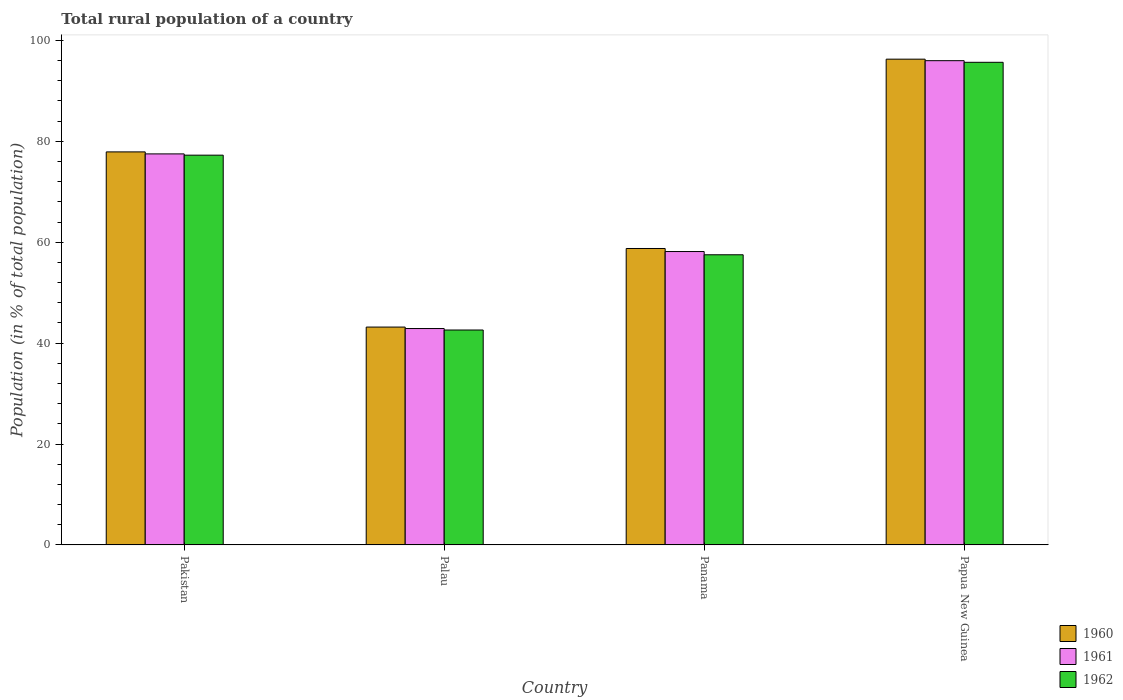How many groups of bars are there?
Give a very brief answer. 4. What is the label of the 4th group of bars from the left?
Keep it short and to the point. Papua New Guinea. What is the rural population in 1960 in Panama?
Offer a very short reply. 58.75. Across all countries, what is the maximum rural population in 1962?
Make the answer very short. 95.65. Across all countries, what is the minimum rural population in 1960?
Give a very brief answer. 43.18. In which country was the rural population in 1962 maximum?
Provide a short and direct response. Papua New Guinea. In which country was the rural population in 1961 minimum?
Offer a terse response. Palau. What is the total rural population in 1962 in the graph?
Provide a succinct answer. 273. What is the difference between the rural population in 1962 in Pakistan and that in Papua New Guinea?
Give a very brief answer. -18.4. What is the difference between the rural population in 1960 in Panama and the rural population in 1962 in Pakistan?
Provide a short and direct response. -18.5. What is the average rural population in 1962 per country?
Offer a terse response. 68.25. What is the difference between the rural population of/in 1960 and rural population of/in 1961 in Palau?
Your answer should be compact. 0.29. What is the ratio of the rural population in 1960 in Palau to that in Panama?
Keep it short and to the point. 0.73. Is the difference between the rural population in 1960 in Palau and Panama greater than the difference between the rural population in 1961 in Palau and Panama?
Keep it short and to the point. No. What is the difference between the highest and the second highest rural population in 1961?
Your response must be concise. -19.35. What is the difference between the highest and the lowest rural population in 1960?
Ensure brevity in your answer.  53.1. Is the sum of the rural population in 1962 in Palau and Panama greater than the maximum rural population in 1961 across all countries?
Your answer should be very brief. Yes. What does the 3rd bar from the left in Palau represents?
Offer a terse response. 1962. What does the 2nd bar from the right in Pakistan represents?
Your answer should be very brief. 1961. Is it the case that in every country, the sum of the rural population in 1961 and rural population in 1960 is greater than the rural population in 1962?
Ensure brevity in your answer.  Yes. Are all the bars in the graph horizontal?
Ensure brevity in your answer.  No. Does the graph contain any zero values?
Your answer should be compact. No. Does the graph contain grids?
Ensure brevity in your answer.  No. What is the title of the graph?
Your answer should be very brief. Total rural population of a country. Does "1993" appear as one of the legend labels in the graph?
Keep it short and to the point. No. What is the label or title of the X-axis?
Offer a very short reply. Country. What is the label or title of the Y-axis?
Your response must be concise. Population (in % of total population). What is the Population (in % of total population) in 1960 in Pakistan?
Give a very brief answer. 77.9. What is the Population (in % of total population) in 1961 in Pakistan?
Provide a succinct answer. 77.5. What is the Population (in % of total population) in 1962 in Pakistan?
Offer a very short reply. 77.25. What is the Population (in % of total population) in 1960 in Palau?
Offer a terse response. 43.18. What is the Population (in % of total population) in 1961 in Palau?
Provide a short and direct response. 42.89. What is the Population (in % of total population) in 1962 in Palau?
Your answer should be compact. 42.59. What is the Population (in % of total population) of 1960 in Panama?
Provide a succinct answer. 58.75. What is the Population (in % of total population) of 1961 in Panama?
Your answer should be very brief. 58.15. What is the Population (in % of total population) in 1962 in Panama?
Provide a succinct answer. 57.51. What is the Population (in % of total population) of 1960 in Papua New Guinea?
Keep it short and to the point. 96.28. What is the Population (in % of total population) of 1961 in Papua New Guinea?
Provide a short and direct response. 95.98. What is the Population (in % of total population) of 1962 in Papua New Guinea?
Keep it short and to the point. 95.65. Across all countries, what is the maximum Population (in % of total population) in 1960?
Make the answer very short. 96.28. Across all countries, what is the maximum Population (in % of total population) of 1961?
Offer a terse response. 95.98. Across all countries, what is the maximum Population (in % of total population) of 1962?
Provide a short and direct response. 95.65. Across all countries, what is the minimum Population (in % of total population) of 1960?
Your answer should be compact. 43.18. Across all countries, what is the minimum Population (in % of total population) in 1961?
Give a very brief answer. 42.89. Across all countries, what is the minimum Population (in % of total population) in 1962?
Your answer should be very brief. 42.59. What is the total Population (in % of total population) of 1960 in the graph?
Give a very brief answer. 276.1. What is the total Population (in % of total population) in 1961 in the graph?
Your response must be concise. 274.51. What is the total Population (in % of total population) of 1962 in the graph?
Offer a terse response. 273. What is the difference between the Population (in % of total population) of 1960 in Pakistan and that in Palau?
Your response must be concise. 34.72. What is the difference between the Population (in % of total population) of 1961 in Pakistan and that in Palau?
Your answer should be compact. 34.61. What is the difference between the Population (in % of total population) of 1962 in Pakistan and that in Palau?
Make the answer very short. 34.65. What is the difference between the Population (in % of total population) in 1960 in Pakistan and that in Panama?
Ensure brevity in your answer.  19.14. What is the difference between the Population (in % of total population) in 1961 in Pakistan and that in Panama?
Offer a terse response. 19.35. What is the difference between the Population (in % of total population) in 1962 in Pakistan and that in Panama?
Your response must be concise. 19.74. What is the difference between the Population (in % of total population) of 1960 in Pakistan and that in Papua New Guinea?
Offer a very short reply. -18.38. What is the difference between the Population (in % of total population) of 1961 in Pakistan and that in Papua New Guinea?
Offer a terse response. -18.48. What is the difference between the Population (in % of total population) of 1962 in Pakistan and that in Papua New Guinea?
Keep it short and to the point. -18.4. What is the difference between the Population (in % of total population) in 1960 in Palau and that in Panama?
Ensure brevity in your answer.  -15.57. What is the difference between the Population (in % of total population) of 1961 in Palau and that in Panama?
Provide a short and direct response. -15.26. What is the difference between the Population (in % of total population) of 1962 in Palau and that in Panama?
Provide a succinct answer. -14.91. What is the difference between the Population (in % of total population) in 1960 in Palau and that in Papua New Guinea?
Provide a short and direct response. -53.1. What is the difference between the Population (in % of total population) in 1961 in Palau and that in Papua New Guinea?
Ensure brevity in your answer.  -53.09. What is the difference between the Population (in % of total population) of 1962 in Palau and that in Papua New Guinea?
Keep it short and to the point. -53.06. What is the difference between the Population (in % of total population) in 1960 in Panama and that in Papua New Guinea?
Your answer should be compact. -37.52. What is the difference between the Population (in % of total population) of 1961 in Panama and that in Papua New Guinea?
Offer a very short reply. -37.83. What is the difference between the Population (in % of total population) of 1962 in Panama and that in Papua New Guinea?
Offer a very short reply. -38.15. What is the difference between the Population (in % of total population) of 1960 in Pakistan and the Population (in % of total population) of 1961 in Palau?
Your answer should be compact. 35.01. What is the difference between the Population (in % of total population) in 1960 in Pakistan and the Population (in % of total population) in 1962 in Palau?
Offer a very short reply. 35.3. What is the difference between the Population (in % of total population) in 1961 in Pakistan and the Population (in % of total population) in 1962 in Palau?
Your answer should be very brief. 34.9. What is the difference between the Population (in % of total population) of 1960 in Pakistan and the Population (in % of total population) of 1961 in Panama?
Offer a terse response. 19.75. What is the difference between the Population (in % of total population) in 1960 in Pakistan and the Population (in % of total population) in 1962 in Panama?
Offer a very short reply. 20.39. What is the difference between the Population (in % of total population) in 1961 in Pakistan and the Population (in % of total population) in 1962 in Panama?
Provide a succinct answer. 19.99. What is the difference between the Population (in % of total population) of 1960 in Pakistan and the Population (in % of total population) of 1961 in Papua New Guinea?
Provide a short and direct response. -18.08. What is the difference between the Population (in % of total population) of 1960 in Pakistan and the Population (in % of total population) of 1962 in Papua New Guinea?
Make the answer very short. -17.76. What is the difference between the Population (in % of total population) of 1961 in Pakistan and the Population (in % of total population) of 1962 in Papua New Guinea?
Offer a very short reply. -18.15. What is the difference between the Population (in % of total population) of 1960 in Palau and the Population (in % of total population) of 1961 in Panama?
Offer a very short reply. -14.97. What is the difference between the Population (in % of total population) of 1960 in Palau and the Population (in % of total population) of 1962 in Panama?
Your answer should be very brief. -14.33. What is the difference between the Population (in % of total population) of 1961 in Palau and the Population (in % of total population) of 1962 in Panama?
Provide a short and direct response. -14.62. What is the difference between the Population (in % of total population) in 1960 in Palau and the Population (in % of total population) in 1961 in Papua New Guinea?
Make the answer very short. -52.8. What is the difference between the Population (in % of total population) of 1960 in Palau and the Population (in % of total population) of 1962 in Papua New Guinea?
Your response must be concise. -52.48. What is the difference between the Population (in % of total population) in 1961 in Palau and the Population (in % of total population) in 1962 in Papua New Guinea?
Offer a very short reply. -52.77. What is the difference between the Population (in % of total population) in 1960 in Panama and the Population (in % of total population) in 1961 in Papua New Guinea?
Keep it short and to the point. -37.23. What is the difference between the Population (in % of total population) in 1960 in Panama and the Population (in % of total population) in 1962 in Papua New Guinea?
Make the answer very short. -36.9. What is the difference between the Population (in % of total population) of 1961 in Panama and the Population (in % of total population) of 1962 in Papua New Guinea?
Offer a terse response. -37.51. What is the average Population (in % of total population) of 1960 per country?
Your answer should be compact. 69.02. What is the average Population (in % of total population) of 1961 per country?
Offer a very short reply. 68.63. What is the average Population (in % of total population) of 1962 per country?
Provide a short and direct response. 68.25. What is the difference between the Population (in % of total population) of 1960 and Population (in % of total population) of 1961 in Pakistan?
Offer a terse response. 0.4. What is the difference between the Population (in % of total population) in 1960 and Population (in % of total population) in 1962 in Pakistan?
Your answer should be compact. 0.65. What is the difference between the Population (in % of total population) in 1960 and Population (in % of total population) in 1961 in Palau?
Make the answer very short. 0.29. What is the difference between the Population (in % of total population) in 1960 and Population (in % of total population) in 1962 in Palau?
Your response must be concise. 0.58. What is the difference between the Population (in % of total population) of 1961 and Population (in % of total population) of 1962 in Palau?
Provide a short and direct response. 0.29. What is the difference between the Population (in % of total population) in 1960 and Population (in % of total population) in 1961 in Panama?
Offer a very short reply. 0.6. What is the difference between the Population (in % of total population) of 1960 and Population (in % of total population) of 1962 in Panama?
Offer a very short reply. 1.25. What is the difference between the Population (in % of total population) in 1961 and Population (in % of total population) in 1962 in Panama?
Offer a very short reply. 0.64. What is the difference between the Population (in % of total population) of 1960 and Population (in % of total population) of 1961 in Papua New Guinea?
Provide a succinct answer. 0.3. What is the difference between the Population (in % of total population) in 1960 and Population (in % of total population) in 1962 in Papua New Guinea?
Your answer should be very brief. 0.62. What is the difference between the Population (in % of total population) of 1961 and Population (in % of total population) of 1962 in Papua New Guinea?
Offer a terse response. 0.32. What is the ratio of the Population (in % of total population) in 1960 in Pakistan to that in Palau?
Your answer should be compact. 1.8. What is the ratio of the Population (in % of total population) in 1961 in Pakistan to that in Palau?
Keep it short and to the point. 1.81. What is the ratio of the Population (in % of total population) of 1962 in Pakistan to that in Palau?
Your response must be concise. 1.81. What is the ratio of the Population (in % of total population) in 1960 in Pakistan to that in Panama?
Ensure brevity in your answer.  1.33. What is the ratio of the Population (in % of total population) of 1961 in Pakistan to that in Panama?
Provide a succinct answer. 1.33. What is the ratio of the Population (in % of total population) in 1962 in Pakistan to that in Panama?
Offer a very short reply. 1.34. What is the ratio of the Population (in % of total population) in 1960 in Pakistan to that in Papua New Guinea?
Your response must be concise. 0.81. What is the ratio of the Population (in % of total population) in 1961 in Pakistan to that in Papua New Guinea?
Provide a succinct answer. 0.81. What is the ratio of the Population (in % of total population) of 1962 in Pakistan to that in Papua New Guinea?
Ensure brevity in your answer.  0.81. What is the ratio of the Population (in % of total population) in 1960 in Palau to that in Panama?
Your response must be concise. 0.73. What is the ratio of the Population (in % of total population) in 1961 in Palau to that in Panama?
Your answer should be compact. 0.74. What is the ratio of the Population (in % of total population) of 1962 in Palau to that in Panama?
Your answer should be compact. 0.74. What is the ratio of the Population (in % of total population) in 1960 in Palau to that in Papua New Guinea?
Offer a very short reply. 0.45. What is the ratio of the Population (in % of total population) in 1961 in Palau to that in Papua New Guinea?
Ensure brevity in your answer.  0.45. What is the ratio of the Population (in % of total population) of 1962 in Palau to that in Papua New Guinea?
Ensure brevity in your answer.  0.45. What is the ratio of the Population (in % of total population) of 1960 in Panama to that in Papua New Guinea?
Ensure brevity in your answer.  0.61. What is the ratio of the Population (in % of total population) of 1961 in Panama to that in Papua New Guinea?
Offer a very short reply. 0.61. What is the ratio of the Population (in % of total population) in 1962 in Panama to that in Papua New Guinea?
Provide a succinct answer. 0.6. What is the difference between the highest and the second highest Population (in % of total population) of 1960?
Provide a succinct answer. 18.38. What is the difference between the highest and the second highest Population (in % of total population) of 1961?
Your answer should be very brief. 18.48. What is the difference between the highest and the second highest Population (in % of total population) in 1962?
Offer a terse response. 18.4. What is the difference between the highest and the lowest Population (in % of total population) of 1960?
Provide a short and direct response. 53.1. What is the difference between the highest and the lowest Population (in % of total population) of 1961?
Offer a very short reply. 53.09. What is the difference between the highest and the lowest Population (in % of total population) of 1962?
Provide a short and direct response. 53.06. 